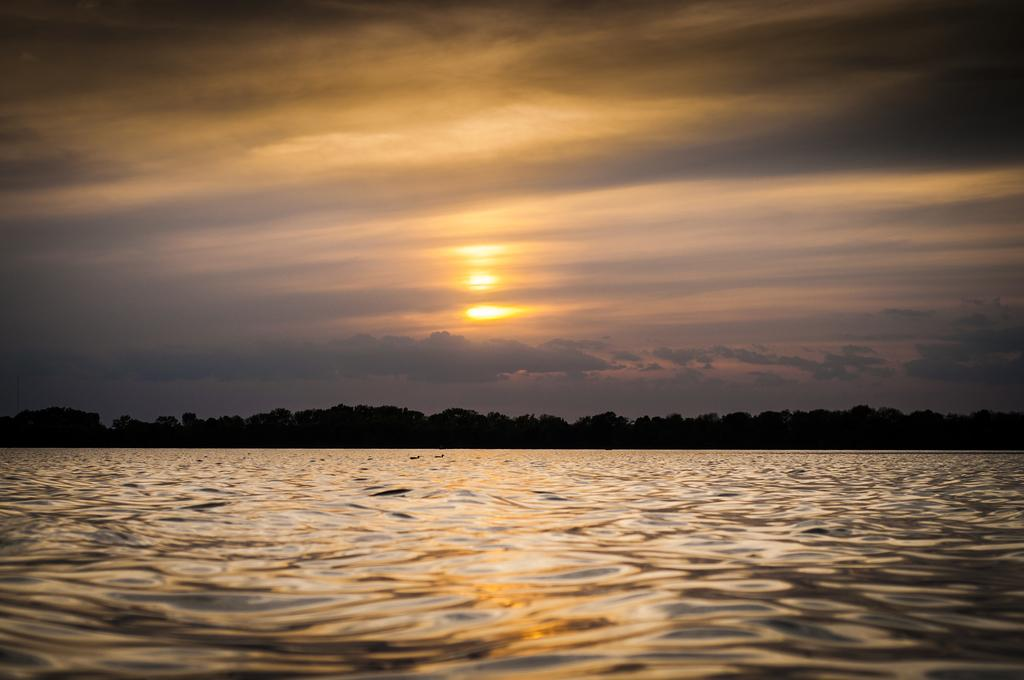What can be seen in the background of the image? There is a beautiful view of the ocean in the background of the image. What type of vegetation is visible in the image? Trees are visible in the image. What celestial body can be seen in the sky? The sun is observable in the image. What atmospheric conditions are present in the sky? Clouds are present in the image. What is the desire of the clouds in the image? The clouds in the image do not have desires, as they are inanimate objects. 